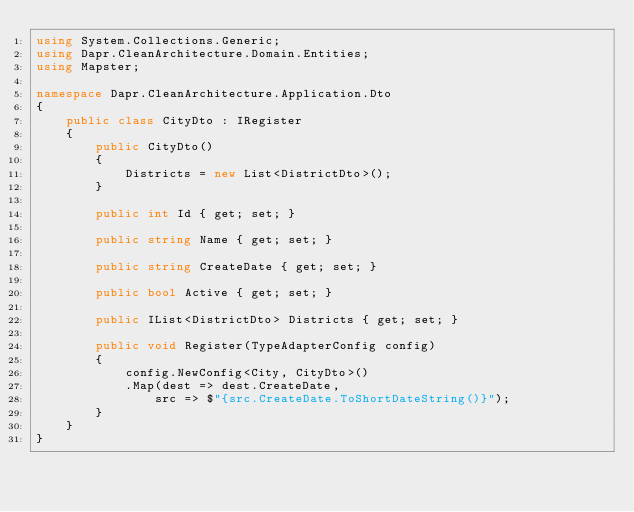<code> <loc_0><loc_0><loc_500><loc_500><_C#_>using System.Collections.Generic;
using Dapr.CleanArchitecture.Domain.Entities;
using Mapster;

namespace Dapr.CleanArchitecture.Application.Dto
{
    public class CityDto : IRegister 
    {
        public CityDto()
        {
            Districts = new List<DistrictDto>();
        }

        public int Id { get; set; }

        public string Name { get; set; }

        public string CreateDate { get; set; }

        public bool Active { get; set; }

        public IList<DistrictDto> Districts { get; set; }

        public void Register(TypeAdapterConfig config)
        {
            config.NewConfig<City, CityDto>()
            .Map(dest => dest.CreateDate,
                src => $"{src.CreateDate.ToShortDateString()}");
        }
    }
}
</code> 